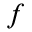Convert formula to latex. <formula><loc_0><loc_0><loc_500><loc_500>f</formula> 